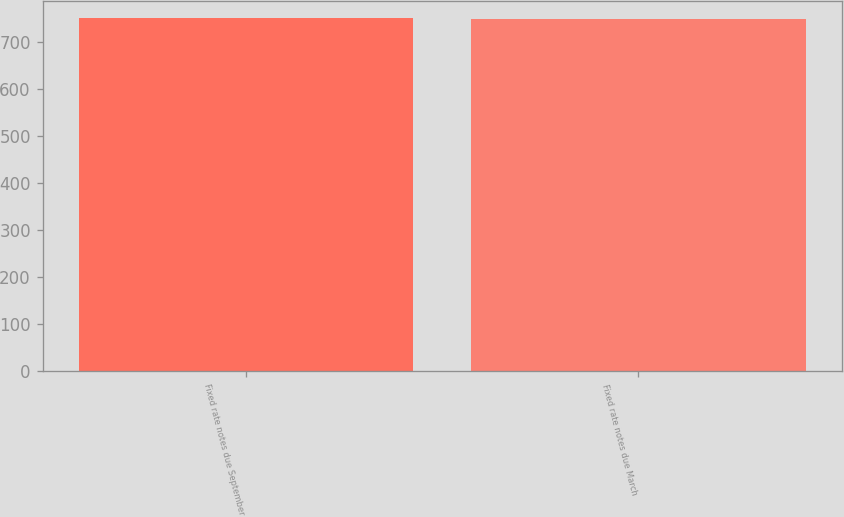<chart> <loc_0><loc_0><loc_500><loc_500><bar_chart><fcel>Fixed rate notes due September<fcel>Fixed rate notes due March<nl><fcel>750.2<fcel>750.1<nl></chart> 